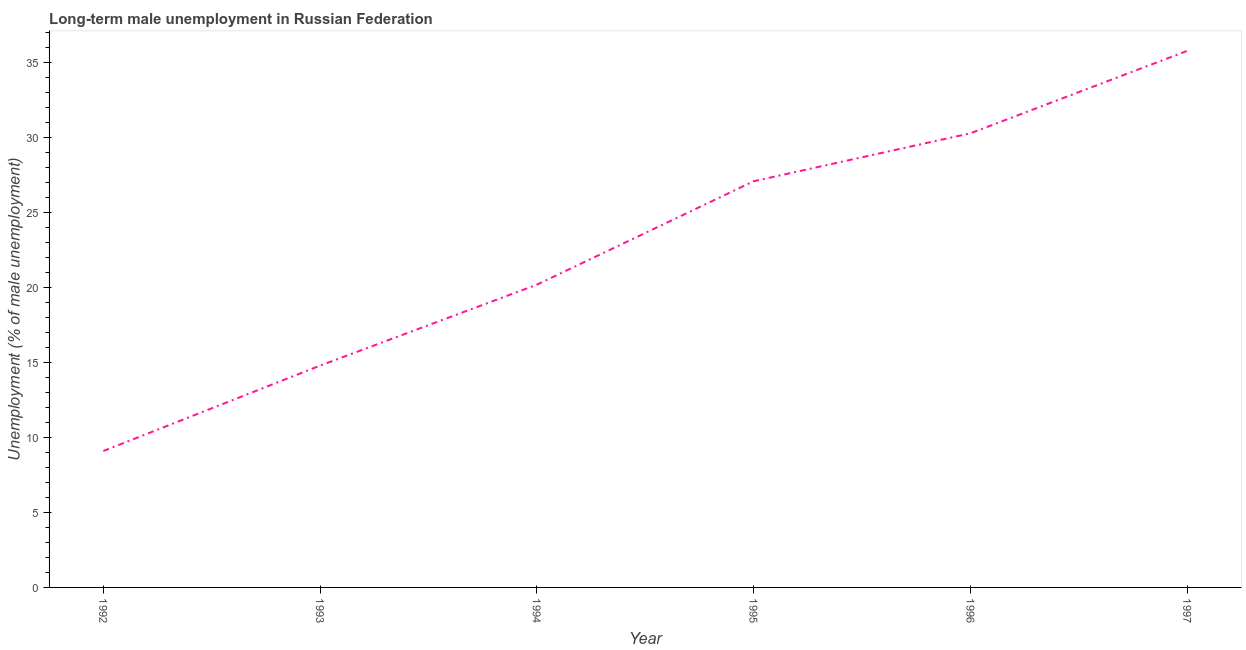What is the long-term male unemployment in 1993?
Your answer should be very brief. 14.8. Across all years, what is the maximum long-term male unemployment?
Keep it short and to the point. 35.8. Across all years, what is the minimum long-term male unemployment?
Provide a short and direct response. 9.1. In which year was the long-term male unemployment maximum?
Your answer should be very brief. 1997. What is the sum of the long-term male unemployment?
Offer a terse response. 137.3. What is the difference between the long-term male unemployment in 1992 and 1994?
Make the answer very short. -11.1. What is the average long-term male unemployment per year?
Keep it short and to the point. 22.88. What is the median long-term male unemployment?
Provide a succinct answer. 23.65. In how many years, is the long-term male unemployment greater than 27 %?
Your answer should be very brief. 3. Do a majority of the years between 1997 and 1992 (inclusive) have long-term male unemployment greater than 26 %?
Offer a terse response. Yes. What is the ratio of the long-term male unemployment in 1992 to that in 1993?
Offer a terse response. 0.61. What is the difference between the highest and the second highest long-term male unemployment?
Keep it short and to the point. 5.5. Is the sum of the long-term male unemployment in 1992 and 1994 greater than the maximum long-term male unemployment across all years?
Provide a succinct answer. No. What is the difference between the highest and the lowest long-term male unemployment?
Give a very brief answer. 26.7. In how many years, is the long-term male unemployment greater than the average long-term male unemployment taken over all years?
Give a very brief answer. 3. Does the long-term male unemployment monotonically increase over the years?
Your answer should be compact. Yes. How many lines are there?
Provide a short and direct response. 1. How many years are there in the graph?
Provide a short and direct response. 6. Are the values on the major ticks of Y-axis written in scientific E-notation?
Offer a terse response. No. Does the graph contain any zero values?
Your answer should be compact. No. What is the title of the graph?
Keep it short and to the point. Long-term male unemployment in Russian Federation. What is the label or title of the Y-axis?
Your response must be concise. Unemployment (% of male unemployment). What is the Unemployment (% of male unemployment) in 1992?
Your response must be concise. 9.1. What is the Unemployment (% of male unemployment) of 1993?
Provide a succinct answer. 14.8. What is the Unemployment (% of male unemployment) in 1994?
Offer a very short reply. 20.2. What is the Unemployment (% of male unemployment) of 1995?
Your answer should be compact. 27.1. What is the Unemployment (% of male unemployment) in 1996?
Provide a short and direct response. 30.3. What is the Unemployment (% of male unemployment) of 1997?
Offer a terse response. 35.8. What is the difference between the Unemployment (% of male unemployment) in 1992 and 1995?
Your answer should be compact. -18. What is the difference between the Unemployment (% of male unemployment) in 1992 and 1996?
Ensure brevity in your answer.  -21.2. What is the difference between the Unemployment (% of male unemployment) in 1992 and 1997?
Keep it short and to the point. -26.7. What is the difference between the Unemployment (% of male unemployment) in 1993 and 1994?
Keep it short and to the point. -5.4. What is the difference between the Unemployment (% of male unemployment) in 1993 and 1996?
Your answer should be compact. -15.5. What is the difference between the Unemployment (% of male unemployment) in 1993 and 1997?
Give a very brief answer. -21. What is the difference between the Unemployment (% of male unemployment) in 1994 and 1997?
Offer a terse response. -15.6. What is the difference between the Unemployment (% of male unemployment) in 1995 and 1997?
Provide a short and direct response. -8.7. What is the ratio of the Unemployment (% of male unemployment) in 1992 to that in 1993?
Offer a terse response. 0.61. What is the ratio of the Unemployment (% of male unemployment) in 1992 to that in 1994?
Keep it short and to the point. 0.45. What is the ratio of the Unemployment (% of male unemployment) in 1992 to that in 1995?
Ensure brevity in your answer.  0.34. What is the ratio of the Unemployment (% of male unemployment) in 1992 to that in 1996?
Your answer should be very brief. 0.3. What is the ratio of the Unemployment (% of male unemployment) in 1992 to that in 1997?
Your response must be concise. 0.25. What is the ratio of the Unemployment (% of male unemployment) in 1993 to that in 1994?
Provide a succinct answer. 0.73. What is the ratio of the Unemployment (% of male unemployment) in 1993 to that in 1995?
Offer a very short reply. 0.55. What is the ratio of the Unemployment (% of male unemployment) in 1993 to that in 1996?
Your response must be concise. 0.49. What is the ratio of the Unemployment (% of male unemployment) in 1993 to that in 1997?
Offer a very short reply. 0.41. What is the ratio of the Unemployment (% of male unemployment) in 1994 to that in 1995?
Keep it short and to the point. 0.74. What is the ratio of the Unemployment (% of male unemployment) in 1994 to that in 1996?
Give a very brief answer. 0.67. What is the ratio of the Unemployment (% of male unemployment) in 1994 to that in 1997?
Make the answer very short. 0.56. What is the ratio of the Unemployment (% of male unemployment) in 1995 to that in 1996?
Ensure brevity in your answer.  0.89. What is the ratio of the Unemployment (% of male unemployment) in 1995 to that in 1997?
Offer a terse response. 0.76. What is the ratio of the Unemployment (% of male unemployment) in 1996 to that in 1997?
Provide a short and direct response. 0.85. 